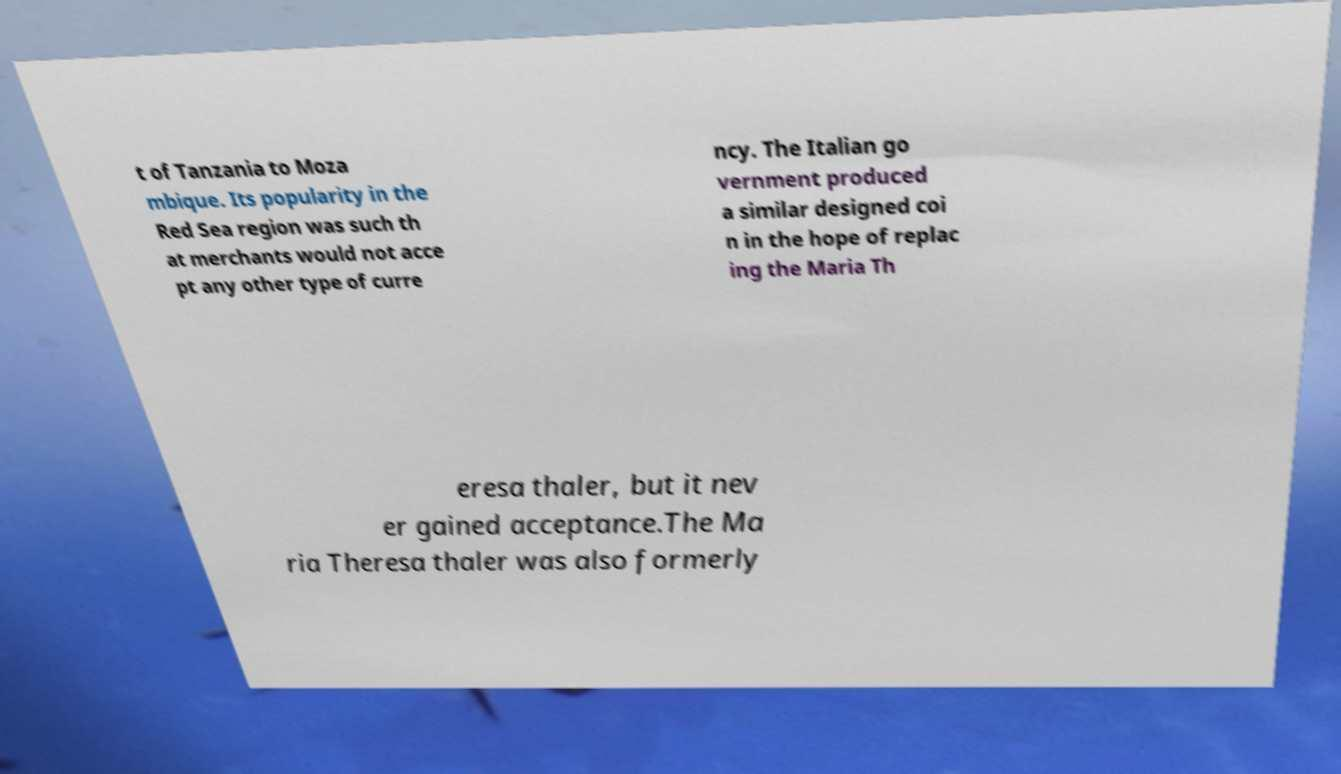Please read and relay the text visible in this image. What does it say? t of Tanzania to Moza mbique. Its popularity in the Red Sea region was such th at merchants would not acce pt any other type of curre ncy. The Italian go vernment produced a similar designed coi n in the hope of replac ing the Maria Th eresa thaler, but it nev er gained acceptance.The Ma ria Theresa thaler was also formerly 